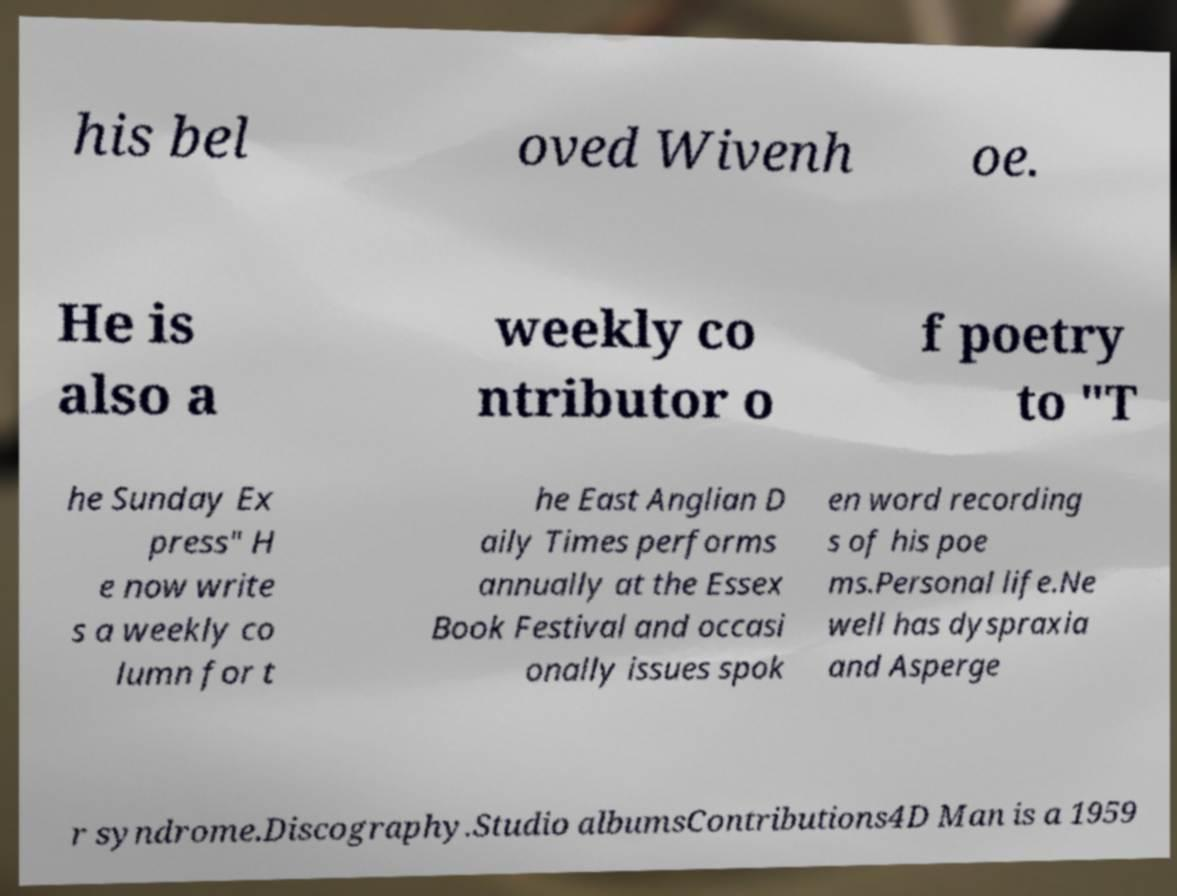Please identify and transcribe the text found in this image. his bel oved Wivenh oe. He is also a weekly co ntributor o f poetry to "T he Sunday Ex press" H e now write s a weekly co lumn for t he East Anglian D aily Times performs annually at the Essex Book Festival and occasi onally issues spok en word recording s of his poe ms.Personal life.Ne well has dyspraxia and Asperge r syndrome.Discography.Studio albumsContributions4D Man is a 1959 